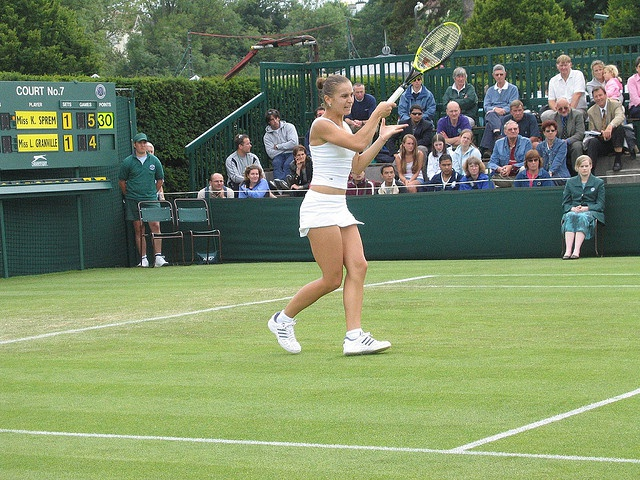Describe the objects in this image and their specific colors. I can see people in darkgreen, gray, black, and navy tones, people in darkgreen, white, tan, and gray tones, people in darkgreen, teal, black, and gray tones, people in darkgreen, teal, and lightgray tones, and people in darkgreen, black, gray, and darkgray tones in this image. 